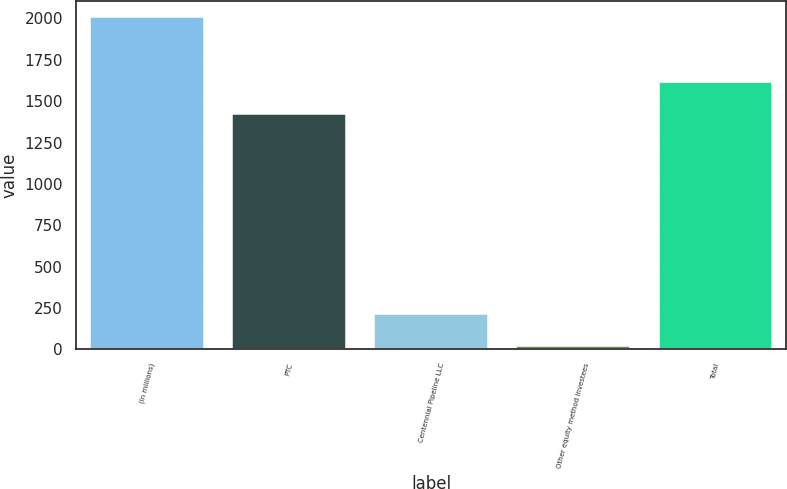<chart> <loc_0><loc_0><loc_500><loc_500><bar_chart><fcel>(In millions)<fcel>PTC<fcel>Centennial Pipeline LLC<fcel>Other equity method investees<fcel>Total<nl><fcel>2006<fcel>1420<fcel>216.8<fcel>18<fcel>1618.8<nl></chart> 